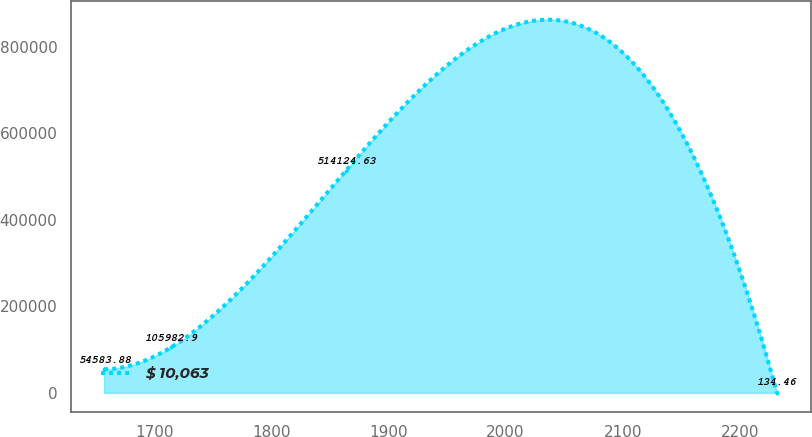Convert chart. <chart><loc_0><loc_0><loc_500><loc_500><line_chart><ecel><fcel>$ 10,063<nl><fcel>1657.27<fcel>54583.9<nl><fcel>1714.72<fcel>105983<nl><fcel>1863.68<fcel>514125<nl><fcel>2231.74<fcel>134.46<nl></chart> 